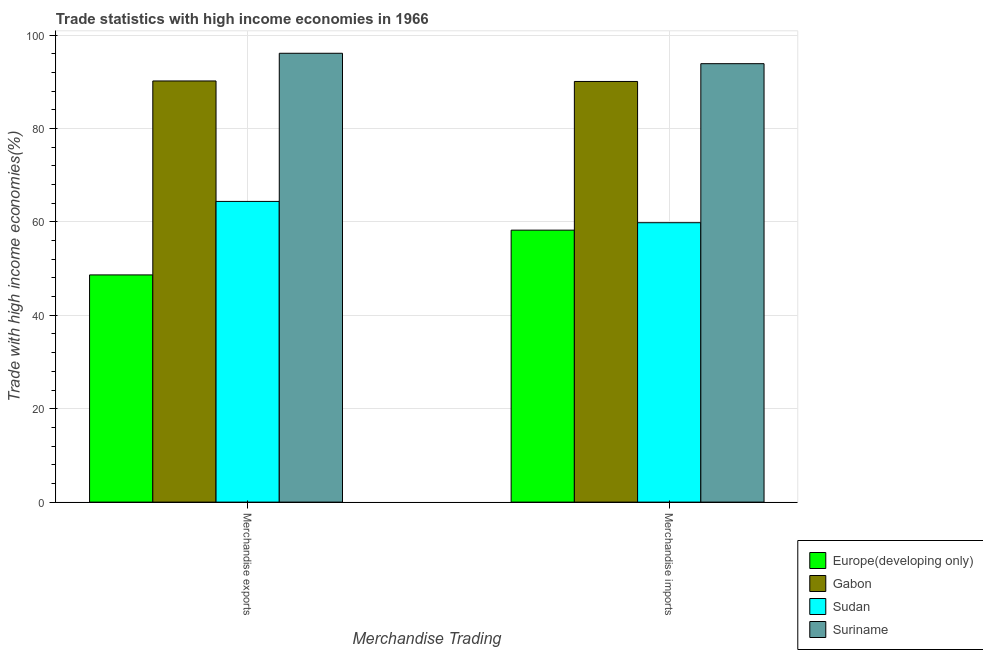Are the number of bars on each tick of the X-axis equal?
Ensure brevity in your answer.  Yes. What is the merchandise imports in Europe(developing only)?
Provide a succinct answer. 58.23. Across all countries, what is the maximum merchandise exports?
Offer a very short reply. 96.1. Across all countries, what is the minimum merchandise imports?
Provide a succinct answer. 58.23. In which country was the merchandise exports maximum?
Keep it short and to the point. Suriname. In which country was the merchandise exports minimum?
Offer a very short reply. Europe(developing only). What is the total merchandise exports in the graph?
Your answer should be compact. 299.29. What is the difference between the merchandise exports in Suriname and that in Gabon?
Offer a terse response. 5.93. What is the difference between the merchandise imports in Gabon and the merchandise exports in Europe(developing only)?
Your response must be concise. 41.41. What is the average merchandise imports per country?
Give a very brief answer. 75.49. What is the difference between the merchandise exports and merchandise imports in Sudan?
Offer a very short reply. 4.56. In how many countries, is the merchandise imports greater than 80 %?
Keep it short and to the point. 2. What is the ratio of the merchandise imports in Gabon to that in Sudan?
Your response must be concise. 1.51. Is the merchandise exports in Gabon less than that in Europe(developing only)?
Provide a succinct answer. No. In how many countries, is the merchandise exports greater than the average merchandise exports taken over all countries?
Your answer should be very brief. 2. What does the 2nd bar from the left in Merchandise imports represents?
Give a very brief answer. Gabon. What does the 1st bar from the right in Merchandise exports represents?
Provide a succinct answer. Suriname. How many bars are there?
Your response must be concise. 8. How many countries are there in the graph?
Offer a very short reply. 4. What is the difference between two consecutive major ticks on the Y-axis?
Keep it short and to the point. 20. Are the values on the major ticks of Y-axis written in scientific E-notation?
Provide a succinct answer. No. Does the graph contain grids?
Give a very brief answer. Yes. How many legend labels are there?
Your answer should be compact. 4. What is the title of the graph?
Provide a short and direct response. Trade statistics with high income economies in 1966. Does "Timor-Leste" appear as one of the legend labels in the graph?
Provide a short and direct response. No. What is the label or title of the X-axis?
Your answer should be compact. Merchandise Trading. What is the label or title of the Y-axis?
Make the answer very short. Trade with high income economies(%). What is the Trade with high income economies(%) in Europe(developing only) in Merchandise exports?
Your answer should be very brief. 48.65. What is the Trade with high income economies(%) of Gabon in Merchandise exports?
Provide a succinct answer. 90.17. What is the Trade with high income economies(%) of Sudan in Merchandise exports?
Offer a very short reply. 64.38. What is the Trade with high income economies(%) of Suriname in Merchandise exports?
Provide a short and direct response. 96.1. What is the Trade with high income economies(%) in Europe(developing only) in Merchandise imports?
Provide a succinct answer. 58.23. What is the Trade with high income economies(%) of Gabon in Merchandise imports?
Provide a succinct answer. 90.06. What is the Trade with high income economies(%) in Sudan in Merchandise imports?
Ensure brevity in your answer.  59.82. What is the Trade with high income economies(%) of Suriname in Merchandise imports?
Your response must be concise. 93.87. Across all Merchandise Trading, what is the maximum Trade with high income economies(%) of Europe(developing only)?
Keep it short and to the point. 58.23. Across all Merchandise Trading, what is the maximum Trade with high income economies(%) of Gabon?
Provide a succinct answer. 90.17. Across all Merchandise Trading, what is the maximum Trade with high income economies(%) of Sudan?
Offer a terse response. 64.38. Across all Merchandise Trading, what is the maximum Trade with high income economies(%) in Suriname?
Your answer should be compact. 96.1. Across all Merchandise Trading, what is the minimum Trade with high income economies(%) in Europe(developing only)?
Your response must be concise. 48.65. Across all Merchandise Trading, what is the minimum Trade with high income economies(%) in Gabon?
Offer a terse response. 90.06. Across all Merchandise Trading, what is the minimum Trade with high income economies(%) of Sudan?
Give a very brief answer. 59.82. Across all Merchandise Trading, what is the minimum Trade with high income economies(%) in Suriname?
Ensure brevity in your answer.  93.87. What is the total Trade with high income economies(%) of Europe(developing only) in the graph?
Ensure brevity in your answer.  106.87. What is the total Trade with high income economies(%) of Gabon in the graph?
Your answer should be very brief. 180.23. What is the total Trade with high income economies(%) in Sudan in the graph?
Make the answer very short. 124.2. What is the total Trade with high income economies(%) in Suriname in the graph?
Provide a short and direct response. 189.96. What is the difference between the Trade with high income economies(%) of Europe(developing only) in Merchandise exports and that in Merchandise imports?
Offer a very short reply. -9.58. What is the difference between the Trade with high income economies(%) in Gabon in Merchandise exports and that in Merchandise imports?
Offer a terse response. 0.11. What is the difference between the Trade with high income economies(%) in Sudan in Merchandise exports and that in Merchandise imports?
Your answer should be very brief. 4.56. What is the difference between the Trade with high income economies(%) of Suriname in Merchandise exports and that in Merchandise imports?
Provide a succinct answer. 2.23. What is the difference between the Trade with high income economies(%) of Europe(developing only) in Merchandise exports and the Trade with high income economies(%) of Gabon in Merchandise imports?
Give a very brief answer. -41.41. What is the difference between the Trade with high income economies(%) of Europe(developing only) in Merchandise exports and the Trade with high income economies(%) of Sudan in Merchandise imports?
Your answer should be very brief. -11.17. What is the difference between the Trade with high income economies(%) of Europe(developing only) in Merchandise exports and the Trade with high income economies(%) of Suriname in Merchandise imports?
Provide a short and direct response. -45.22. What is the difference between the Trade with high income economies(%) of Gabon in Merchandise exports and the Trade with high income economies(%) of Sudan in Merchandise imports?
Make the answer very short. 30.35. What is the difference between the Trade with high income economies(%) in Gabon in Merchandise exports and the Trade with high income economies(%) in Suriname in Merchandise imports?
Keep it short and to the point. -3.7. What is the difference between the Trade with high income economies(%) in Sudan in Merchandise exports and the Trade with high income economies(%) in Suriname in Merchandise imports?
Make the answer very short. -29.49. What is the average Trade with high income economies(%) of Europe(developing only) per Merchandise Trading?
Your response must be concise. 53.44. What is the average Trade with high income economies(%) in Gabon per Merchandise Trading?
Ensure brevity in your answer.  90.11. What is the average Trade with high income economies(%) in Sudan per Merchandise Trading?
Ensure brevity in your answer.  62.1. What is the average Trade with high income economies(%) in Suriname per Merchandise Trading?
Ensure brevity in your answer.  94.98. What is the difference between the Trade with high income economies(%) in Europe(developing only) and Trade with high income economies(%) in Gabon in Merchandise exports?
Give a very brief answer. -41.52. What is the difference between the Trade with high income economies(%) in Europe(developing only) and Trade with high income economies(%) in Sudan in Merchandise exports?
Provide a short and direct response. -15.74. What is the difference between the Trade with high income economies(%) in Europe(developing only) and Trade with high income economies(%) in Suriname in Merchandise exports?
Your answer should be compact. -47.45. What is the difference between the Trade with high income economies(%) of Gabon and Trade with high income economies(%) of Sudan in Merchandise exports?
Your answer should be compact. 25.79. What is the difference between the Trade with high income economies(%) in Gabon and Trade with high income economies(%) in Suriname in Merchandise exports?
Give a very brief answer. -5.93. What is the difference between the Trade with high income economies(%) of Sudan and Trade with high income economies(%) of Suriname in Merchandise exports?
Provide a short and direct response. -31.72. What is the difference between the Trade with high income economies(%) in Europe(developing only) and Trade with high income economies(%) in Gabon in Merchandise imports?
Ensure brevity in your answer.  -31.83. What is the difference between the Trade with high income economies(%) of Europe(developing only) and Trade with high income economies(%) of Sudan in Merchandise imports?
Provide a succinct answer. -1.59. What is the difference between the Trade with high income economies(%) in Europe(developing only) and Trade with high income economies(%) in Suriname in Merchandise imports?
Give a very brief answer. -35.64. What is the difference between the Trade with high income economies(%) of Gabon and Trade with high income economies(%) of Sudan in Merchandise imports?
Give a very brief answer. 30.24. What is the difference between the Trade with high income economies(%) in Gabon and Trade with high income economies(%) in Suriname in Merchandise imports?
Make the answer very short. -3.81. What is the difference between the Trade with high income economies(%) of Sudan and Trade with high income economies(%) of Suriname in Merchandise imports?
Provide a succinct answer. -34.05. What is the ratio of the Trade with high income economies(%) of Europe(developing only) in Merchandise exports to that in Merchandise imports?
Keep it short and to the point. 0.84. What is the ratio of the Trade with high income economies(%) of Sudan in Merchandise exports to that in Merchandise imports?
Offer a terse response. 1.08. What is the ratio of the Trade with high income economies(%) of Suriname in Merchandise exports to that in Merchandise imports?
Offer a terse response. 1.02. What is the difference between the highest and the second highest Trade with high income economies(%) in Europe(developing only)?
Give a very brief answer. 9.58. What is the difference between the highest and the second highest Trade with high income economies(%) of Gabon?
Provide a succinct answer. 0.11. What is the difference between the highest and the second highest Trade with high income economies(%) of Sudan?
Offer a very short reply. 4.56. What is the difference between the highest and the second highest Trade with high income economies(%) of Suriname?
Provide a short and direct response. 2.23. What is the difference between the highest and the lowest Trade with high income economies(%) of Europe(developing only)?
Make the answer very short. 9.58. What is the difference between the highest and the lowest Trade with high income economies(%) of Gabon?
Your response must be concise. 0.11. What is the difference between the highest and the lowest Trade with high income economies(%) in Sudan?
Keep it short and to the point. 4.56. What is the difference between the highest and the lowest Trade with high income economies(%) of Suriname?
Make the answer very short. 2.23. 